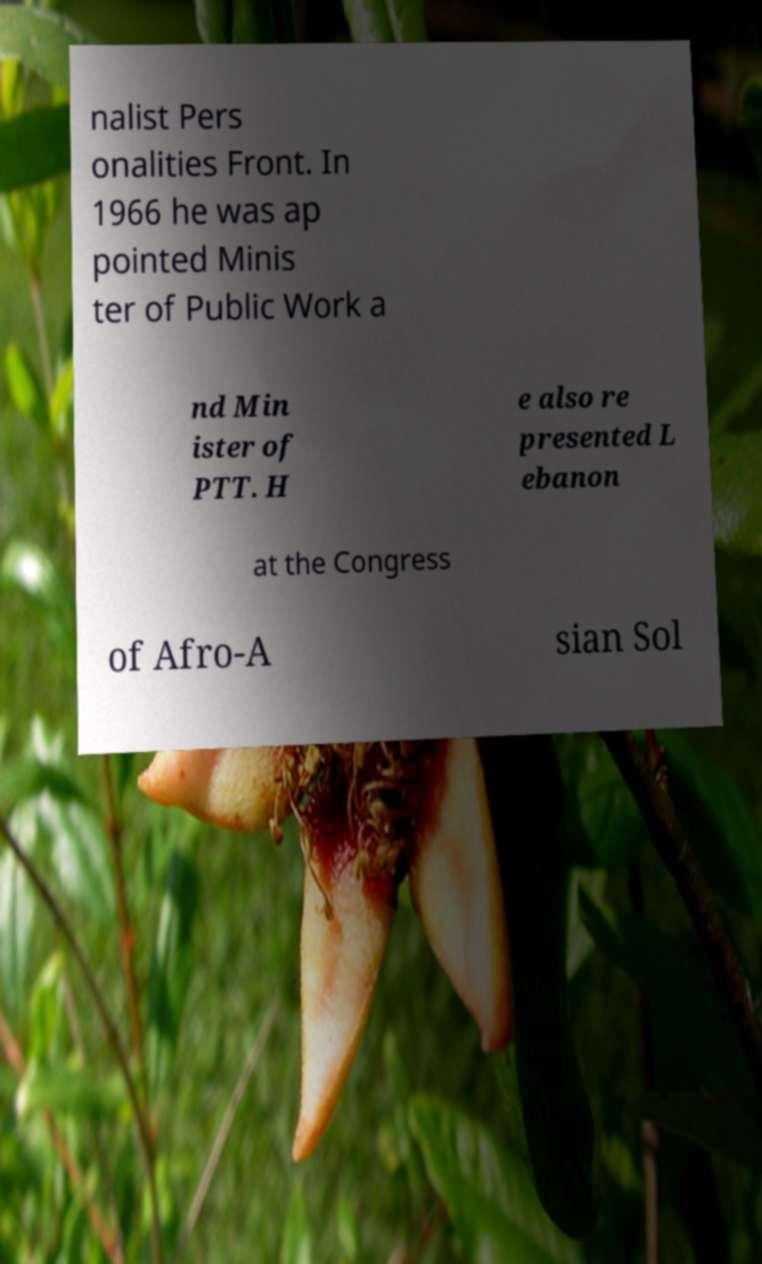There's text embedded in this image that I need extracted. Can you transcribe it verbatim? nalist Pers onalities Front. In 1966 he was ap pointed Minis ter of Public Work a nd Min ister of PTT. H e also re presented L ebanon at the Congress of Afro-A sian Sol 